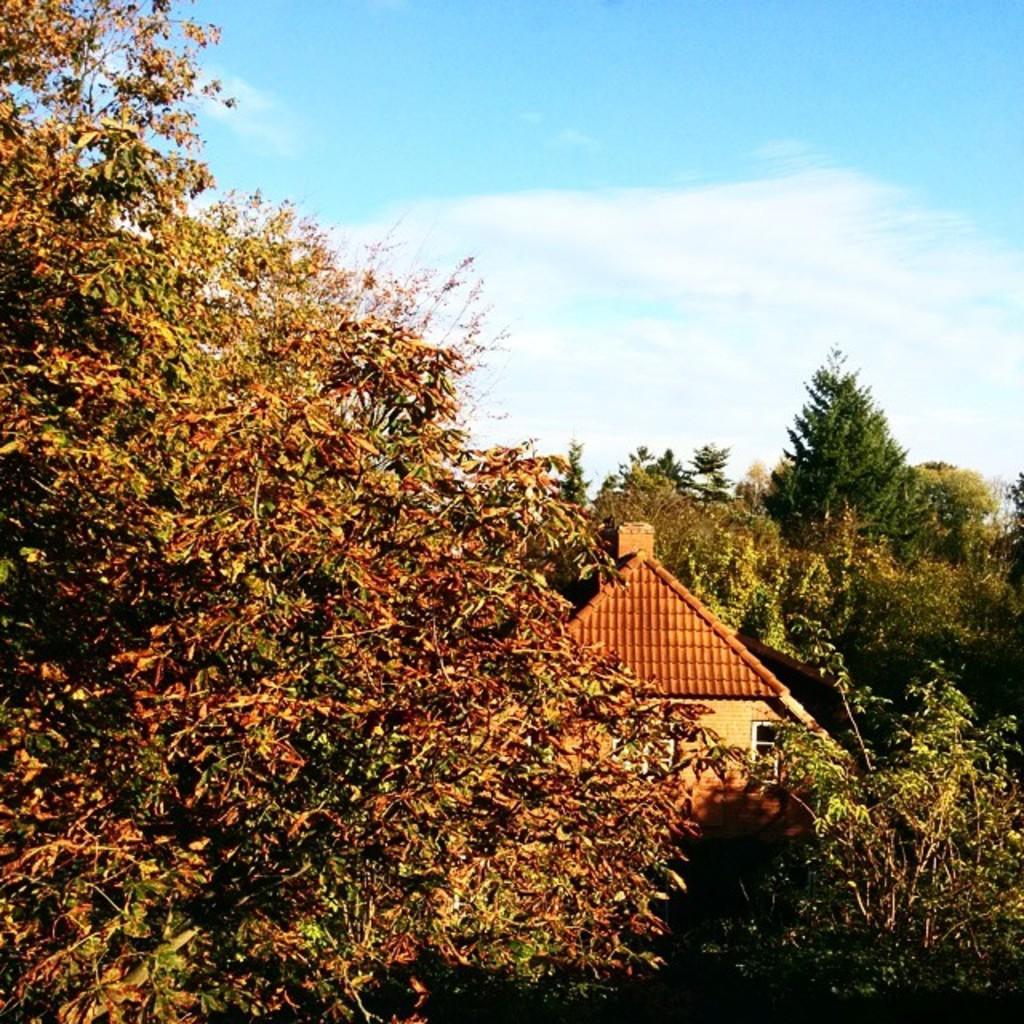In one or two sentences, can you explain what this image depicts? In this picture we can see trees and house. In the background of the image we can see the sky with clouds. 